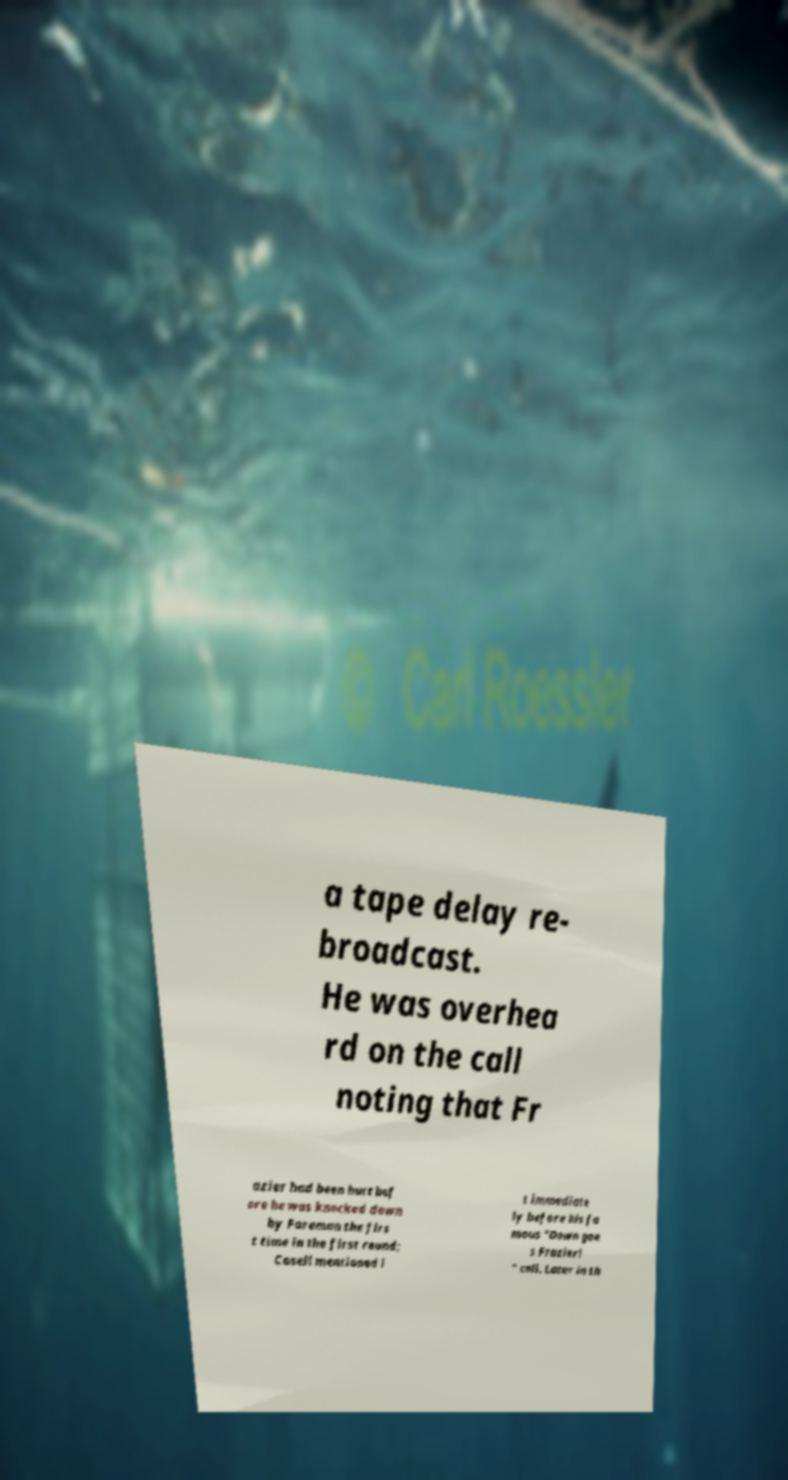Could you extract and type out the text from this image? a tape delay re- broadcast. He was overhea rd on the call noting that Fr azier had been hurt bef ore he was knocked down by Foreman the firs t time in the first round; Cosell mentioned i t immediate ly before his fa mous "Down goe s Frazier! " call. Later in th 